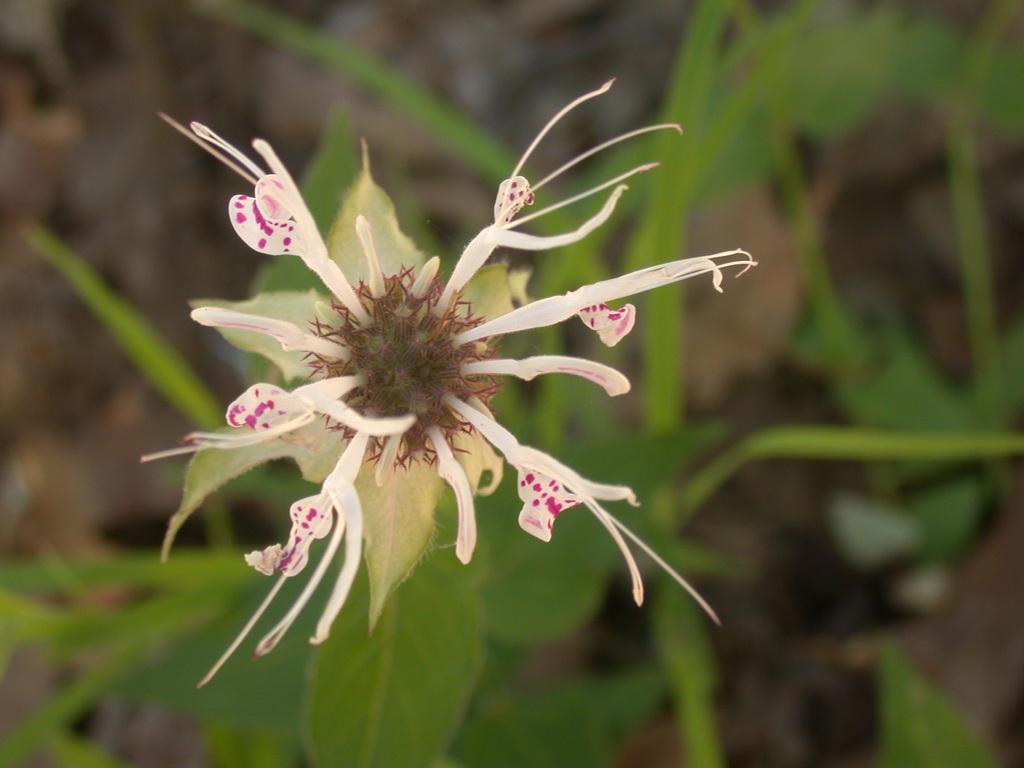Could you give a brief overview of what you see in this image? In this image we can see a flower. At the bottom there are leaves. 